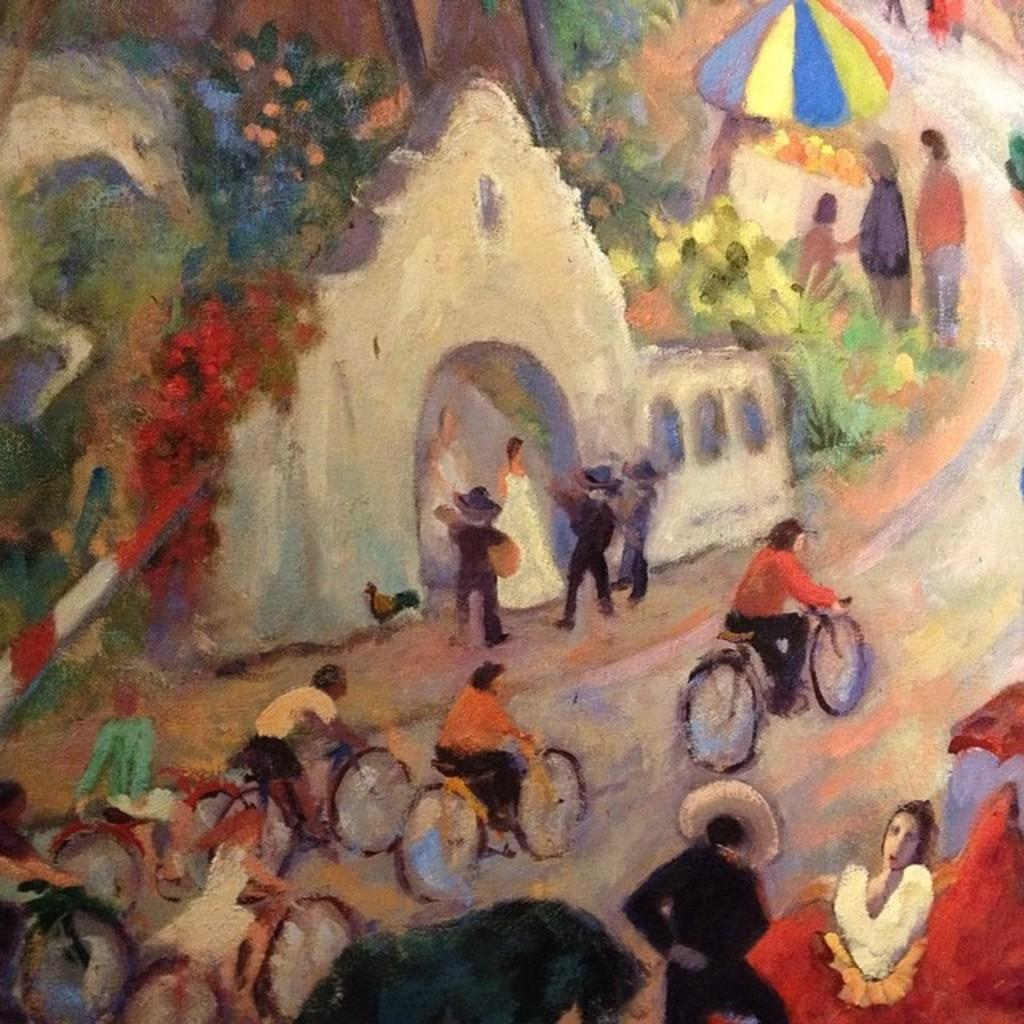What is the main subject of the image? The image contains a painting. What activities are the persons in the painting engaged in? There are persons riding bicycles and standing in the painting. What type of vegetation is present in the painting? There are trees and flowers in the painting. What object can be seen in the painting for protection from the sun or rain? There is an umbrella in the painting. What geographical feature is visible in the painting? There is a mountain in the painting. What type of cheese can be seen being stretched in the painting? There is no cheese present in the painting; it features a landscape with persons, trees, flowers, an umbrella, and a mountain. 